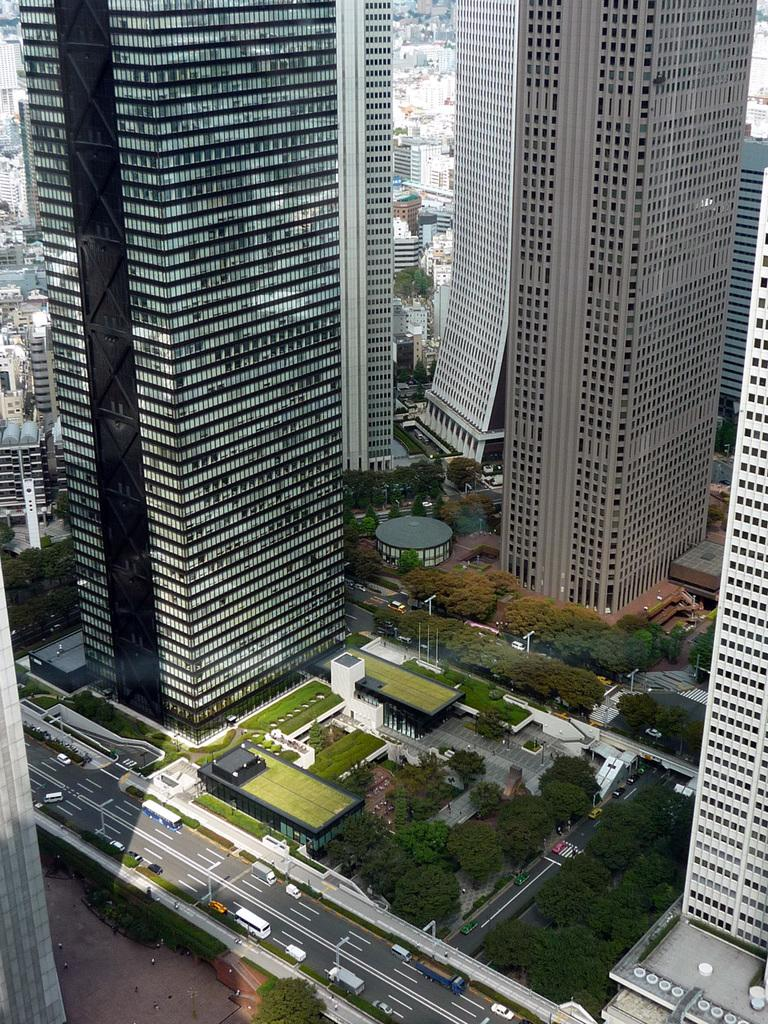What type of view is shown in the image? The image is a top view of a city. What structures can be seen in the image? There are buildings in the image. What connects the buildings in the image? There are roads in the image. What is moving along the roads in the image? There are vehicles in the image. What type of vegetation can be seen in the image? There are trees in the image. How many bones are visible in the image? There are no bones visible in the image; it is a top view of a city with buildings, roads, vehicles, and trees. 